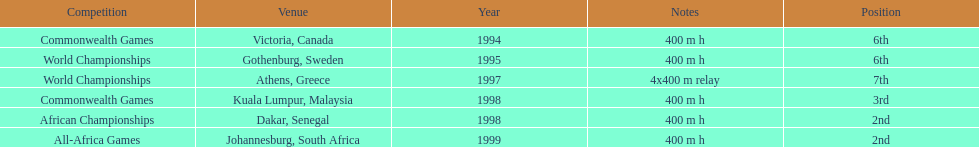What was the location prior to dakar, senegal? Kuala Lumpur, Malaysia. 